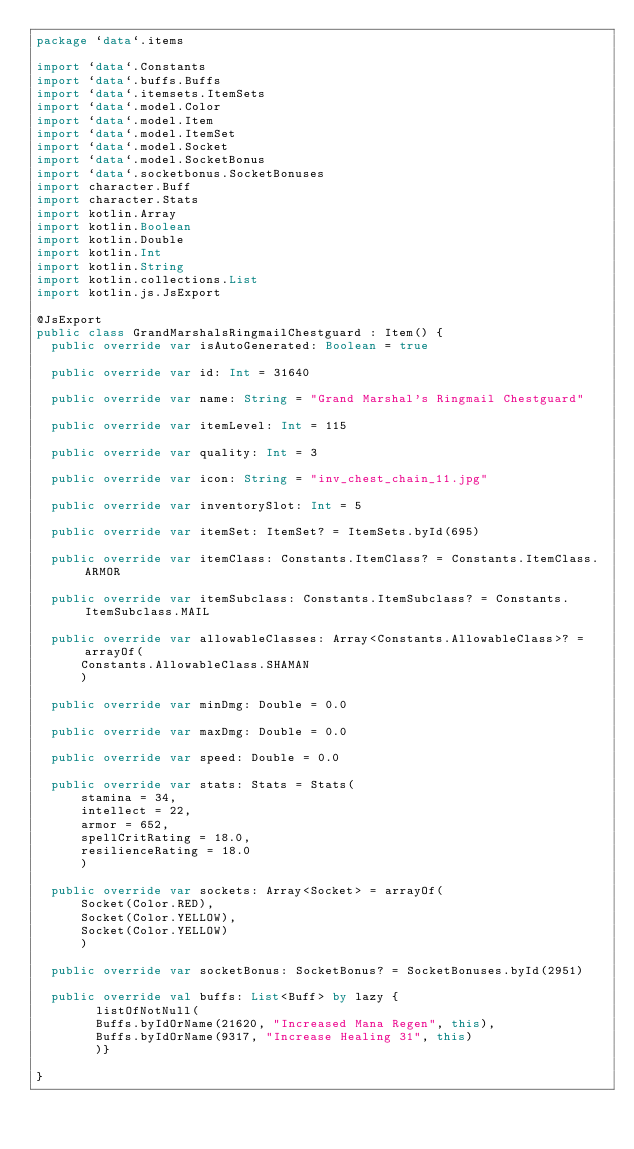Convert code to text. <code><loc_0><loc_0><loc_500><loc_500><_Kotlin_>package `data`.items

import `data`.Constants
import `data`.buffs.Buffs
import `data`.itemsets.ItemSets
import `data`.model.Color
import `data`.model.Item
import `data`.model.ItemSet
import `data`.model.Socket
import `data`.model.SocketBonus
import `data`.socketbonus.SocketBonuses
import character.Buff
import character.Stats
import kotlin.Array
import kotlin.Boolean
import kotlin.Double
import kotlin.Int
import kotlin.String
import kotlin.collections.List
import kotlin.js.JsExport

@JsExport
public class GrandMarshalsRingmailChestguard : Item() {
  public override var isAutoGenerated: Boolean = true

  public override var id: Int = 31640

  public override var name: String = "Grand Marshal's Ringmail Chestguard"

  public override var itemLevel: Int = 115

  public override var quality: Int = 3

  public override var icon: String = "inv_chest_chain_11.jpg"

  public override var inventorySlot: Int = 5

  public override var itemSet: ItemSet? = ItemSets.byId(695)

  public override var itemClass: Constants.ItemClass? = Constants.ItemClass.ARMOR

  public override var itemSubclass: Constants.ItemSubclass? = Constants.ItemSubclass.MAIL

  public override var allowableClasses: Array<Constants.AllowableClass>? = arrayOf(
      Constants.AllowableClass.SHAMAN
      )

  public override var minDmg: Double = 0.0

  public override var maxDmg: Double = 0.0

  public override var speed: Double = 0.0

  public override var stats: Stats = Stats(
      stamina = 34,
      intellect = 22,
      armor = 652,
      spellCritRating = 18.0,
      resilienceRating = 18.0
      )

  public override var sockets: Array<Socket> = arrayOf(
      Socket(Color.RED),
      Socket(Color.YELLOW),
      Socket(Color.YELLOW)
      )

  public override var socketBonus: SocketBonus? = SocketBonuses.byId(2951)

  public override val buffs: List<Buff> by lazy {
        listOfNotNull(
        Buffs.byIdOrName(21620, "Increased Mana Regen", this),
        Buffs.byIdOrName(9317, "Increase Healing 31", this)
        )}

}
</code> 